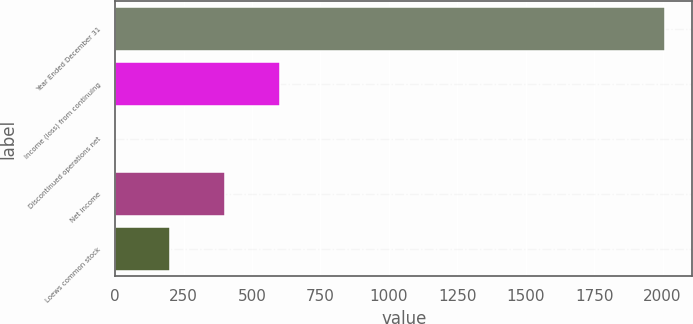Convert chart to OTSL. <chart><loc_0><loc_0><loc_500><loc_500><bar_chart><fcel>Year Ended December 31<fcel>Income (loss) from continuing<fcel>Discontinued operations net<fcel>Net income<fcel>Loews common stock<nl><fcel>2009<fcel>602.71<fcel>0.01<fcel>401.81<fcel>200.91<nl></chart> 